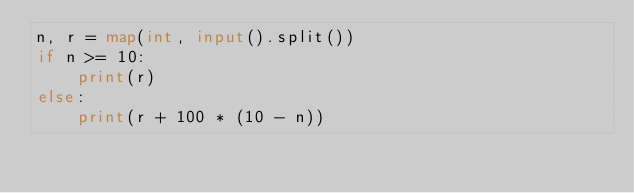Convert code to text. <code><loc_0><loc_0><loc_500><loc_500><_Python_>n, r = map(int, input().split())
if n >= 10:
    print(r)
else:
    print(r + 100 * (10 - n))
</code> 